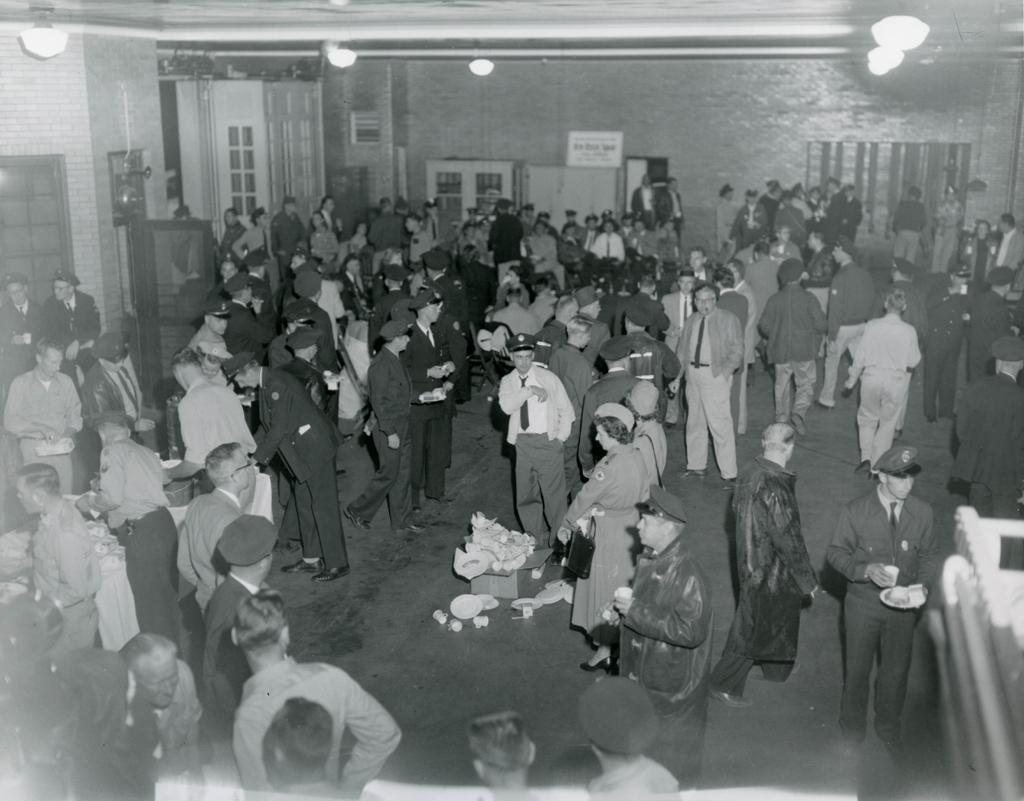Could you give a brief overview of what you see in this image? In this image we can see some people standing and eating food. We can see some food items in their hands. And at the top we can see the lights, ducts. We can see the windows and a board with some text on it. 